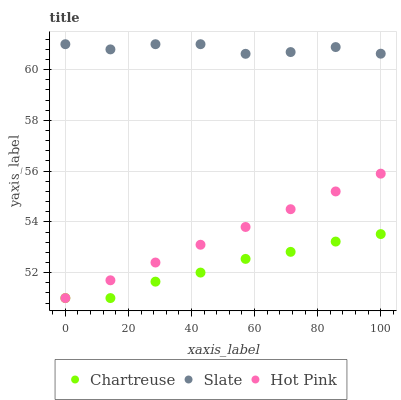Does Chartreuse have the minimum area under the curve?
Answer yes or no. Yes. Does Slate have the maximum area under the curve?
Answer yes or no. Yes. Does Hot Pink have the minimum area under the curve?
Answer yes or no. No. Does Hot Pink have the maximum area under the curve?
Answer yes or no. No. Is Hot Pink the smoothest?
Answer yes or no. Yes. Is Slate the roughest?
Answer yes or no. Yes. Is Slate the smoothest?
Answer yes or no. No. Is Hot Pink the roughest?
Answer yes or no. No. Does Chartreuse have the lowest value?
Answer yes or no. Yes. Does Slate have the lowest value?
Answer yes or no. No. Does Slate have the highest value?
Answer yes or no. Yes. Does Hot Pink have the highest value?
Answer yes or no. No. Is Hot Pink less than Slate?
Answer yes or no. Yes. Is Slate greater than Hot Pink?
Answer yes or no. Yes. Does Chartreuse intersect Hot Pink?
Answer yes or no. Yes. Is Chartreuse less than Hot Pink?
Answer yes or no. No. Is Chartreuse greater than Hot Pink?
Answer yes or no. No. Does Hot Pink intersect Slate?
Answer yes or no. No. 